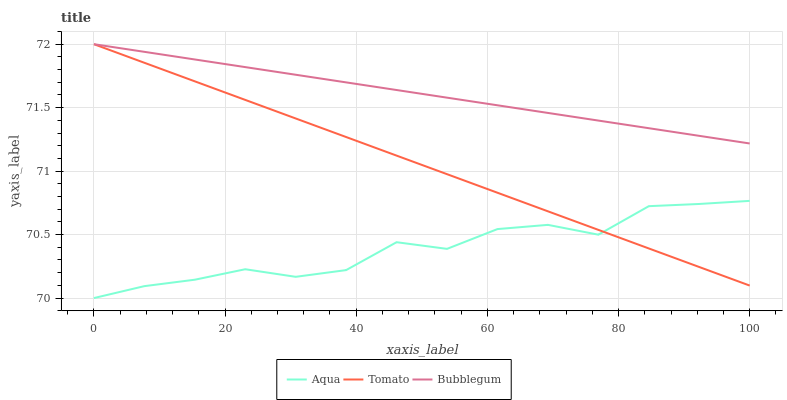Does Aqua have the minimum area under the curve?
Answer yes or no. Yes. Does Bubblegum have the maximum area under the curve?
Answer yes or no. Yes. Does Bubblegum have the minimum area under the curve?
Answer yes or no. No. Does Aqua have the maximum area under the curve?
Answer yes or no. No. Is Bubblegum the smoothest?
Answer yes or no. Yes. Is Aqua the roughest?
Answer yes or no. Yes. Is Aqua the smoothest?
Answer yes or no. No. Is Bubblegum the roughest?
Answer yes or no. No. Does Aqua have the lowest value?
Answer yes or no. Yes. Does Bubblegum have the lowest value?
Answer yes or no. No. Does Bubblegum have the highest value?
Answer yes or no. Yes. Does Aqua have the highest value?
Answer yes or no. No. Is Aqua less than Bubblegum?
Answer yes or no. Yes. Is Bubblegum greater than Aqua?
Answer yes or no. Yes. Does Aqua intersect Tomato?
Answer yes or no. Yes. Is Aqua less than Tomato?
Answer yes or no. No. Is Aqua greater than Tomato?
Answer yes or no. No. Does Aqua intersect Bubblegum?
Answer yes or no. No. 